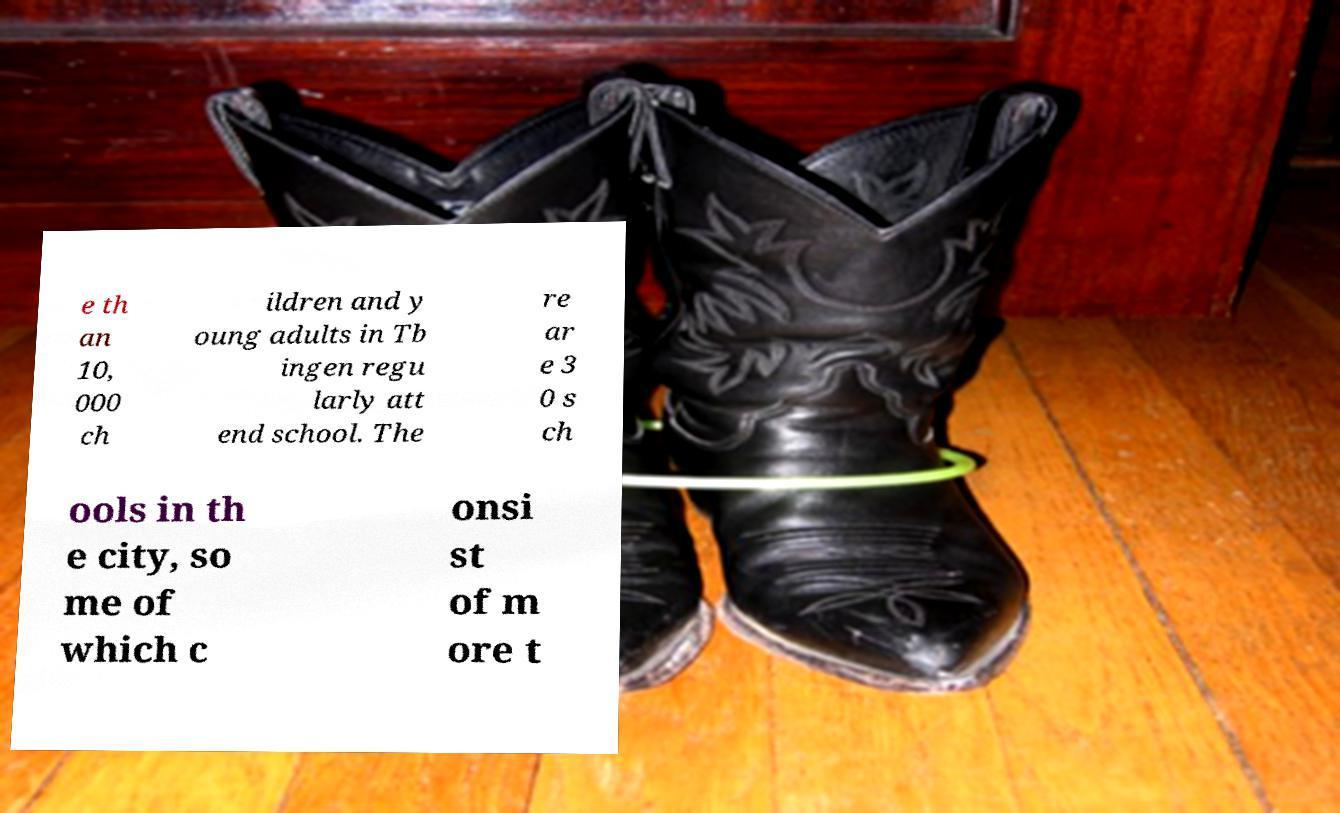Could you extract and type out the text from this image? e th an 10, 000 ch ildren and y oung adults in Tb ingen regu larly att end school. The re ar e 3 0 s ch ools in th e city, so me of which c onsi st of m ore t 